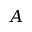<formula> <loc_0><loc_0><loc_500><loc_500>A</formula> 